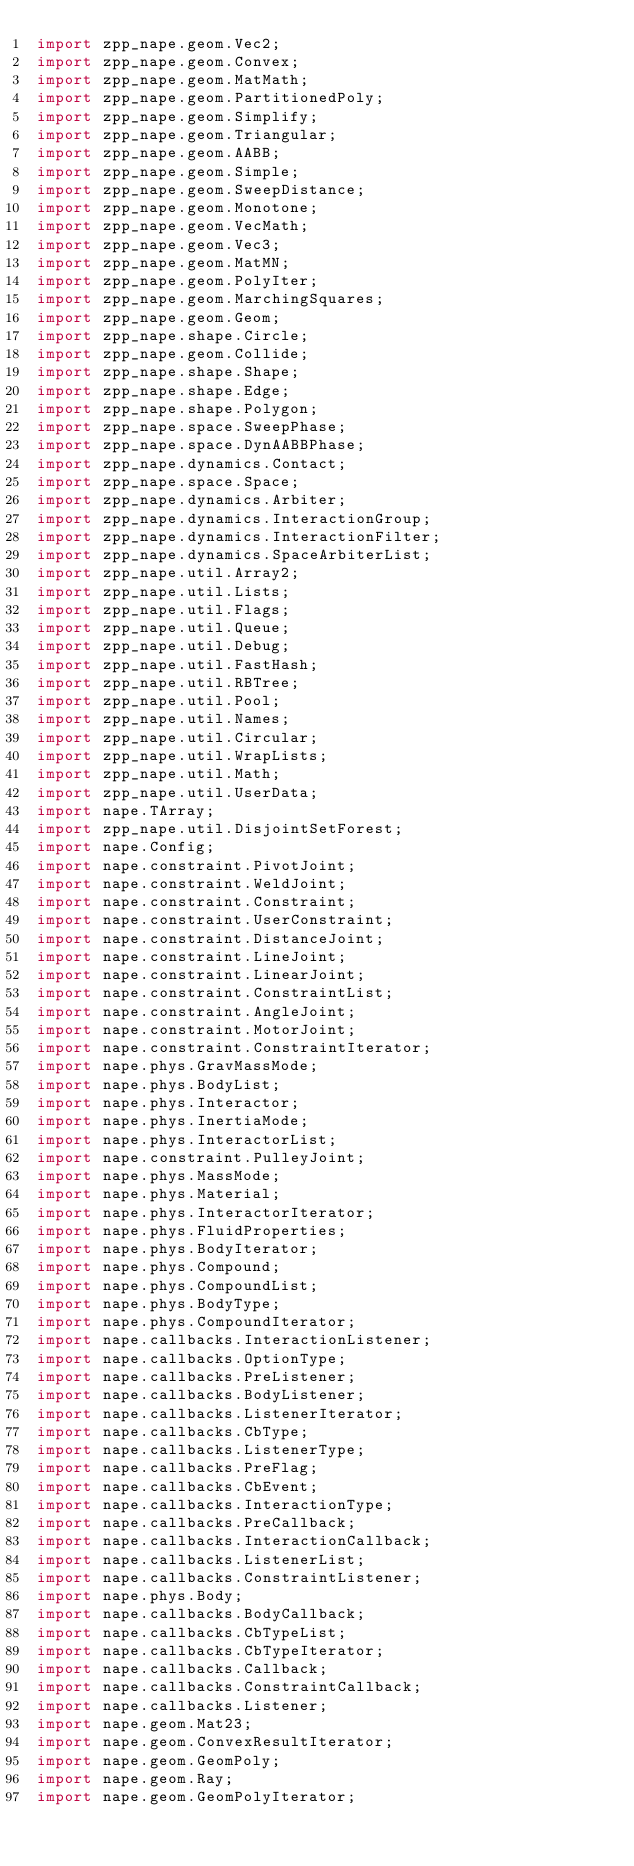<code> <loc_0><loc_0><loc_500><loc_500><_Haxe_>import zpp_nape.geom.Vec2;
import zpp_nape.geom.Convex;
import zpp_nape.geom.MatMath;
import zpp_nape.geom.PartitionedPoly;
import zpp_nape.geom.Simplify;
import zpp_nape.geom.Triangular;
import zpp_nape.geom.AABB;
import zpp_nape.geom.Simple;
import zpp_nape.geom.SweepDistance;
import zpp_nape.geom.Monotone;
import zpp_nape.geom.VecMath;
import zpp_nape.geom.Vec3;
import zpp_nape.geom.MatMN;
import zpp_nape.geom.PolyIter;
import zpp_nape.geom.MarchingSquares;
import zpp_nape.geom.Geom;
import zpp_nape.shape.Circle;
import zpp_nape.geom.Collide;
import zpp_nape.shape.Shape;
import zpp_nape.shape.Edge;
import zpp_nape.shape.Polygon;
import zpp_nape.space.SweepPhase;
import zpp_nape.space.DynAABBPhase;
import zpp_nape.dynamics.Contact;
import zpp_nape.space.Space;
import zpp_nape.dynamics.Arbiter;
import zpp_nape.dynamics.InteractionGroup;
import zpp_nape.dynamics.InteractionFilter;
import zpp_nape.dynamics.SpaceArbiterList;
import zpp_nape.util.Array2;
import zpp_nape.util.Lists;
import zpp_nape.util.Flags;
import zpp_nape.util.Queue;
import zpp_nape.util.Debug;
import zpp_nape.util.FastHash;
import zpp_nape.util.RBTree;
import zpp_nape.util.Pool;
import zpp_nape.util.Names;
import zpp_nape.util.Circular;
import zpp_nape.util.WrapLists;
import zpp_nape.util.Math;
import zpp_nape.util.UserData;
import nape.TArray;
import zpp_nape.util.DisjointSetForest;
import nape.Config;
import nape.constraint.PivotJoint;
import nape.constraint.WeldJoint;
import nape.constraint.Constraint;
import nape.constraint.UserConstraint;
import nape.constraint.DistanceJoint;
import nape.constraint.LineJoint;
import nape.constraint.LinearJoint;
import nape.constraint.ConstraintList;
import nape.constraint.AngleJoint;
import nape.constraint.MotorJoint;
import nape.constraint.ConstraintIterator;
import nape.phys.GravMassMode;
import nape.phys.BodyList;
import nape.phys.Interactor;
import nape.phys.InertiaMode;
import nape.phys.InteractorList;
import nape.constraint.PulleyJoint;
import nape.phys.MassMode;
import nape.phys.Material;
import nape.phys.InteractorIterator;
import nape.phys.FluidProperties;
import nape.phys.BodyIterator;
import nape.phys.Compound;
import nape.phys.CompoundList;
import nape.phys.BodyType;
import nape.phys.CompoundIterator;
import nape.callbacks.InteractionListener;
import nape.callbacks.OptionType;
import nape.callbacks.PreListener;
import nape.callbacks.BodyListener;
import nape.callbacks.ListenerIterator;
import nape.callbacks.CbType;
import nape.callbacks.ListenerType;
import nape.callbacks.PreFlag;
import nape.callbacks.CbEvent;
import nape.callbacks.InteractionType;
import nape.callbacks.PreCallback;
import nape.callbacks.InteractionCallback;
import nape.callbacks.ListenerList;
import nape.callbacks.ConstraintListener;
import nape.phys.Body;
import nape.callbacks.BodyCallback;
import nape.callbacks.CbTypeList;
import nape.callbacks.CbTypeIterator;
import nape.callbacks.Callback;
import nape.callbacks.ConstraintCallback;
import nape.callbacks.Listener;
import nape.geom.Mat23;
import nape.geom.ConvexResultIterator;
import nape.geom.GeomPoly;
import nape.geom.Ray;
import nape.geom.GeomPolyIterator;</code> 